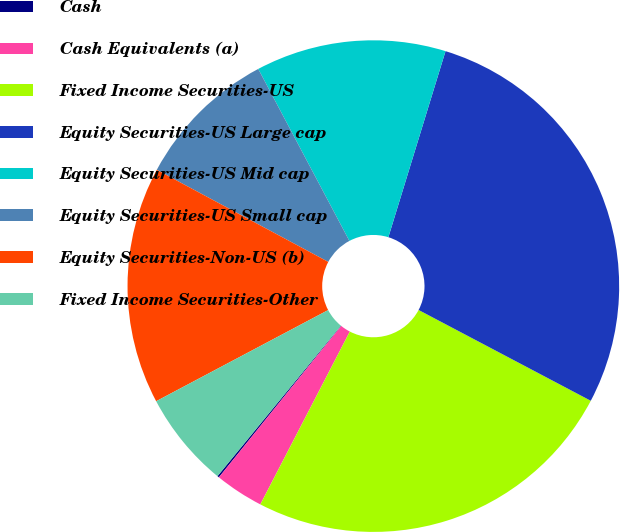Convert chart to OTSL. <chart><loc_0><loc_0><loc_500><loc_500><pie_chart><fcel>Cash<fcel>Cash Equivalents (a)<fcel>Fixed Income Securities-US<fcel>Equity Securities-US Large cap<fcel>Equity Securities-US Mid cap<fcel>Equity Securities-US Small cap<fcel>Equity Securities-Non-US (b)<fcel>Fixed Income Securities-Other<nl><fcel>0.12%<fcel>3.21%<fcel>24.88%<fcel>27.98%<fcel>12.5%<fcel>9.4%<fcel>15.6%<fcel>6.31%<nl></chart> 